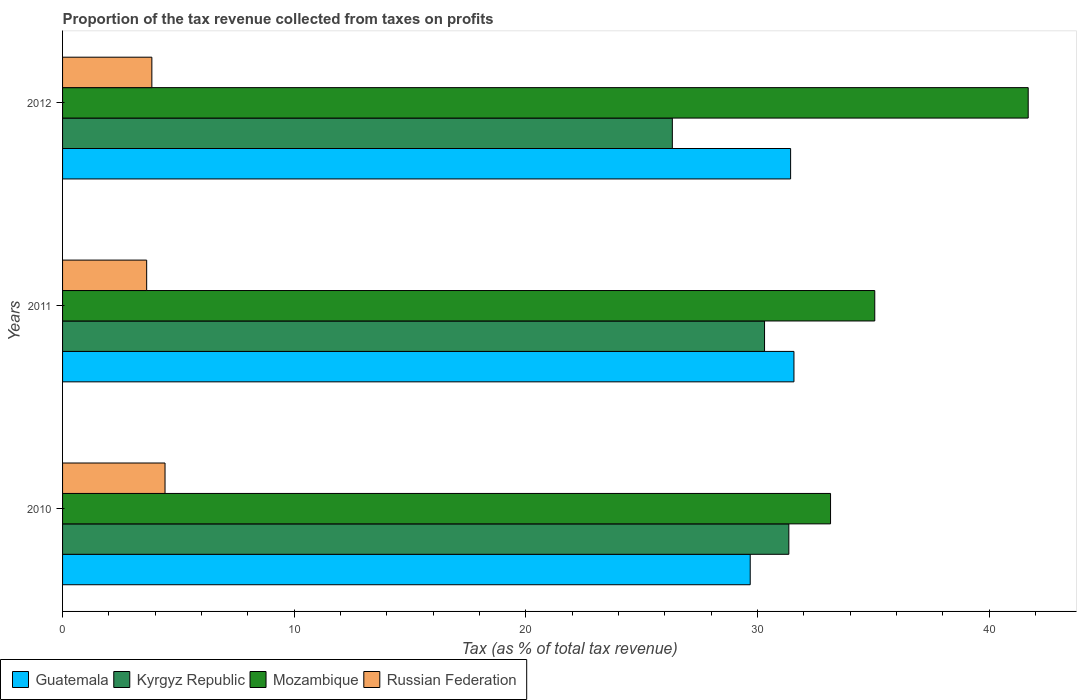Are the number of bars per tick equal to the number of legend labels?
Offer a very short reply. Yes. How many bars are there on the 1st tick from the top?
Offer a very short reply. 4. How many bars are there on the 3rd tick from the bottom?
Your response must be concise. 4. In how many cases, is the number of bars for a given year not equal to the number of legend labels?
Offer a very short reply. 0. What is the proportion of the tax revenue collected in Russian Federation in 2010?
Make the answer very short. 4.42. Across all years, what is the maximum proportion of the tax revenue collected in Mozambique?
Provide a succinct answer. 41.69. Across all years, what is the minimum proportion of the tax revenue collected in Russian Federation?
Offer a very short reply. 3.63. In which year was the proportion of the tax revenue collected in Kyrgyz Republic maximum?
Provide a short and direct response. 2010. What is the total proportion of the tax revenue collected in Kyrgyz Republic in the graph?
Make the answer very short. 87.99. What is the difference between the proportion of the tax revenue collected in Mozambique in 2010 and that in 2012?
Your response must be concise. -8.53. What is the difference between the proportion of the tax revenue collected in Mozambique in 2010 and the proportion of the tax revenue collected in Russian Federation in 2011?
Your answer should be compact. 29.52. What is the average proportion of the tax revenue collected in Guatemala per year?
Your answer should be compact. 30.9. In the year 2011, what is the difference between the proportion of the tax revenue collected in Guatemala and proportion of the tax revenue collected in Russian Federation?
Keep it short and to the point. 27.94. What is the ratio of the proportion of the tax revenue collected in Mozambique in 2011 to that in 2012?
Keep it short and to the point. 0.84. Is the difference between the proportion of the tax revenue collected in Guatemala in 2010 and 2011 greater than the difference between the proportion of the tax revenue collected in Russian Federation in 2010 and 2011?
Keep it short and to the point. No. What is the difference between the highest and the second highest proportion of the tax revenue collected in Kyrgyz Republic?
Ensure brevity in your answer.  1.05. What is the difference between the highest and the lowest proportion of the tax revenue collected in Guatemala?
Make the answer very short. 1.89. In how many years, is the proportion of the tax revenue collected in Kyrgyz Republic greater than the average proportion of the tax revenue collected in Kyrgyz Republic taken over all years?
Your answer should be very brief. 2. What does the 1st bar from the top in 2011 represents?
Make the answer very short. Russian Federation. What does the 3rd bar from the bottom in 2010 represents?
Your answer should be very brief. Mozambique. How many bars are there?
Offer a terse response. 12. How many years are there in the graph?
Make the answer very short. 3. What is the difference between two consecutive major ticks on the X-axis?
Offer a terse response. 10. Does the graph contain grids?
Keep it short and to the point. No. How are the legend labels stacked?
Your response must be concise. Horizontal. What is the title of the graph?
Offer a terse response. Proportion of the tax revenue collected from taxes on profits. Does "Switzerland" appear as one of the legend labels in the graph?
Offer a very short reply. No. What is the label or title of the X-axis?
Offer a very short reply. Tax (as % of total tax revenue). What is the label or title of the Y-axis?
Your answer should be compact. Years. What is the Tax (as % of total tax revenue) of Guatemala in 2010?
Offer a terse response. 29.69. What is the Tax (as % of total tax revenue) in Kyrgyz Republic in 2010?
Give a very brief answer. 31.36. What is the Tax (as % of total tax revenue) of Mozambique in 2010?
Make the answer very short. 33.16. What is the Tax (as % of total tax revenue) in Russian Federation in 2010?
Make the answer very short. 4.42. What is the Tax (as % of total tax revenue) of Guatemala in 2011?
Your answer should be compact. 31.58. What is the Tax (as % of total tax revenue) of Kyrgyz Republic in 2011?
Offer a terse response. 30.31. What is the Tax (as % of total tax revenue) of Mozambique in 2011?
Provide a succinct answer. 35.06. What is the Tax (as % of total tax revenue) of Russian Federation in 2011?
Your answer should be compact. 3.63. What is the Tax (as % of total tax revenue) of Guatemala in 2012?
Ensure brevity in your answer.  31.43. What is the Tax (as % of total tax revenue) of Kyrgyz Republic in 2012?
Offer a very short reply. 26.33. What is the Tax (as % of total tax revenue) of Mozambique in 2012?
Offer a terse response. 41.69. What is the Tax (as % of total tax revenue) in Russian Federation in 2012?
Make the answer very short. 3.85. Across all years, what is the maximum Tax (as % of total tax revenue) in Guatemala?
Your response must be concise. 31.58. Across all years, what is the maximum Tax (as % of total tax revenue) in Kyrgyz Republic?
Provide a succinct answer. 31.36. Across all years, what is the maximum Tax (as % of total tax revenue) of Mozambique?
Provide a succinct answer. 41.69. Across all years, what is the maximum Tax (as % of total tax revenue) of Russian Federation?
Offer a very short reply. 4.42. Across all years, what is the minimum Tax (as % of total tax revenue) in Guatemala?
Keep it short and to the point. 29.69. Across all years, what is the minimum Tax (as % of total tax revenue) in Kyrgyz Republic?
Your answer should be very brief. 26.33. Across all years, what is the minimum Tax (as % of total tax revenue) of Mozambique?
Your answer should be very brief. 33.16. Across all years, what is the minimum Tax (as % of total tax revenue) in Russian Federation?
Offer a terse response. 3.63. What is the total Tax (as % of total tax revenue) in Guatemala in the graph?
Offer a terse response. 92.69. What is the total Tax (as % of total tax revenue) in Kyrgyz Republic in the graph?
Provide a succinct answer. 87.99. What is the total Tax (as % of total tax revenue) in Mozambique in the graph?
Offer a terse response. 109.91. What is the total Tax (as % of total tax revenue) in Russian Federation in the graph?
Your response must be concise. 11.91. What is the difference between the Tax (as % of total tax revenue) of Guatemala in 2010 and that in 2011?
Keep it short and to the point. -1.89. What is the difference between the Tax (as % of total tax revenue) of Kyrgyz Republic in 2010 and that in 2011?
Offer a very short reply. 1.05. What is the difference between the Tax (as % of total tax revenue) of Mozambique in 2010 and that in 2011?
Offer a very short reply. -1.91. What is the difference between the Tax (as % of total tax revenue) of Russian Federation in 2010 and that in 2011?
Make the answer very short. 0.79. What is the difference between the Tax (as % of total tax revenue) in Guatemala in 2010 and that in 2012?
Your answer should be very brief. -1.74. What is the difference between the Tax (as % of total tax revenue) in Kyrgyz Republic in 2010 and that in 2012?
Your answer should be compact. 5.03. What is the difference between the Tax (as % of total tax revenue) of Mozambique in 2010 and that in 2012?
Give a very brief answer. -8.53. What is the difference between the Tax (as % of total tax revenue) in Russian Federation in 2010 and that in 2012?
Ensure brevity in your answer.  0.57. What is the difference between the Tax (as % of total tax revenue) of Guatemala in 2011 and that in 2012?
Your response must be concise. 0.14. What is the difference between the Tax (as % of total tax revenue) in Kyrgyz Republic in 2011 and that in 2012?
Your response must be concise. 3.98. What is the difference between the Tax (as % of total tax revenue) in Mozambique in 2011 and that in 2012?
Offer a terse response. -6.62. What is the difference between the Tax (as % of total tax revenue) in Russian Federation in 2011 and that in 2012?
Provide a short and direct response. -0.22. What is the difference between the Tax (as % of total tax revenue) of Guatemala in 2010 and the Tax (as % of total tax revenue) of Kyrgyz Republic in 2011?
Give a very brief answer. -0.62. What is the difference between the Tax (as % of total tax revenue) in Guatemala in 2010 and the Tax (as % of total tax revenue) in Mozambique in 2011?
Your response must be concise. -5.38. What is the difference between the Tax (as % of total tax revenue) in Guatemala in 2010 and the Tax (as % of total tax revenue) in Russian Federation in 2011?
Your answer should be compact. 26.06. What is the difference between the Tax (as % of total tax revenue) in Kyrgyz Republic in 2010 and the Tax (as % of total tax revenue) in Mozambique in 2011?
Ensure brevity in your answer.  -3.71. What is the difference between the Tax (as % of total tax revenue) of Kyrgyz Republic in 2010 and the Tax (as % of total tax revenue) of Russian Federation in 2011?
Ensure brevity in your answer.  27.72. What is the difference between the Tax (as % of total tax revenue) in Mozambique in 2010 and the Tax (as % of total tax revenue) in Russian Federation in 2011?
Give a very brief answer. 29.52. What is the difference between the Tax (as % of total tax revenue) in Guatemala in 2010 and the Tax (as % of total tax revenue) in Kyrgyz Republic in 2012?
Provide a succinct answer. 3.36. What is the difference between the Tax (as % of total tax revenue) in Guatemala in 2010 and the Tax (as % of total tax revenue) in Mozambique in 2012?
Offer a terse response. -12. What is the difference between the Tax (as % of total tax revenue) of Guatemala in 2010 and the Tax (as % of total tax revenue) of Russian Federation in 2012?
Ensure brevity in your answer.  25.83. What is the difference between the Tax (as % of total tax revenue) in Kyrgyz Republic in 2010 and the Tax (as % of total tax revenue) in Mozambique in 2012?
Keep it short and to the point. -10.33. What is the difference between the Tax (as % of total tax revenue) in Kyrgyz Republic in 2010 and the Tax (as % of total tax revenue) in Russian Federation in 2012?
Ensure brevity in your answer.  27.5. What is the difference between the Tax (as % of total tax revenue) of Mozambique in 2010 and the Tax (as % of total tax revenue) of Russian Federation in 2012?
Your response must be concise. 29.3. What is the difference between the Tax (as % of total tax revenue) in Guatemala in 2011 and the Tax (as % of total tax revenue) in Kyrgyz Republic in 2012?
Ensure brevity in your answer.  5.25. What is the difference between the Tax (as % of total tax revenue) in Guatemala in 2011 and the Tax (as % of total tax revenue) in Mozambique in 2012?
Give a very brief answer. -10.11. What is the difference between the Tax (as % of total tax revenue) of Guatemala in 2011 and the Tax (as % of total tax revenue) of Russian Federation in 2012?
Keep it short and to the point. 27.72. What is the difference between the Tax (as % of total tax revenue) in Kyrgyz Republic in 2011 and the Tax (as % of total tax revenue) in Mozambique in 2012?
Your answer should be compact. -11.38. What is the difference between the Tax (as % of total tax revenue) of Kyrgyz Republic in 2011 and the Tax (as % of total tax revenue) of Russian Federation in 2012?
Offer a very short reply. 26.45. What is the difference between the Tax (as % of total tax revenue) in Mozambique in 2011 and the Tax (as % of total tax revenue) in Russian Federation in 2012?
Your answer should be compact. 31.21. What is the average Tax (as % of total tax revenue) in Guatemala per year?
Keep it short and to the point. 30.9. What is the average Tax (as % of total tax revenue) in Kyrgyz Republic per year?
Provide a succinct answer. 29.33. What is the average Tax (as % of total tax revenue) in Mozambique per year?
Make the answer very short. 36.64. What is the average Tax (as % of total tax revenue) of Russian Federation per year?
Provide a short and direct response. 3.97. In the year 2010, what is the difference between the Tax (as % of total tax revenue) in Guatemala and Tax (as % of total tax revenue) in Kyrgyz Republic?
Make the answer very short. -1.67. In the year 2010, what is the difference between the Tax (as % of total tax revenue) of Guatemala and Tax (as % of total tax revenue) of Mozambique?
Your answer should be compact. -3.47. In the year 2010, what is the difference between the Tax (as % of total tax revenue) of Guatemala and Tax (as % of total tax revenue) of Russian Federation?
Your answer should be very brief. 25.26. In the year 2010, what is the difference between the Tax (as % of total tax revenue) in Kyrgyz Republic and Tax (as % of total tax revenue) in Mozambique?
Ensure brevity in your answer.  -1.8. In the year 2010, what is the difference between the Tax (as % of total tax revenue) in Kyrgyz Republic and Tax (as % of total tax revenue) in Russian Federation?
Your answer should be compact. 26.93. In the year 2010, what is the difference between the Tax (as % of total tax revenue) of Mozambique and Tax (as % of total tax revenue) of Russian Federation?
Offer a terse response. 28.73. In the year 2011, what is the difference between the Tax (as % of total tax revenue) of Guatemala and Tax (as % of total tax revenue) of Kyrgyz Republic?
Ensure brevity in your answer.  1.27. In the year 2011, what is the difference between the Tax (as % of total tax revenue) of Guatemala and Tax (as % of total tax revenue) of Mozambique?
Make the answer very short. -3.49. In the year 2011, what is the difference between the Tax (as % of total tax revenue) in Guatemala and Tax (as % of total tax revenue) in Russian Federation?
Offer a terse response. 27.94. In the year 2011, what is the difference between the Tax (as % of total tax revenue) in Kyrgyz Republic and Tax (as % of total tax revenue) in Mozambique?
Provide a short and direct response. -4.76. In the year 2011, what is the difference between the Tax (as % of total tax revenue) of Kyrgyz Republic and Tax (as % of total tax revenue) of Russian Federation?
Make the answer very short. 26.68. In the year 2011, what is the difference between the Tax (as % of total tax revenue) of Mozambique and Tax (as % of total tax revenue) of Russian Federation?
Give a very brief answer. 31.43. In the year 2012, what is the difference between the Tax (as % of total tax revenue) in Guatemala and Tax (as % of total tax revenue) in Kyrgyz Republic?
Your answer should be compact. 5.11. In the year 2012, what is the difference between the Tax (as % of total tax revenue) in Guatemala and Tax (as % of total tax revenue) in Mozambique?
Your response must be concise. -10.26. In the year 2012, what is the difference between the Tax (as % of total tax revenue) of Guatemala and Tax (as % of total tax revenue) of Russian Federation?
Ensure brevity in your answer.  27.58. In the year 2012, what is the difference between the Tax (as % of total tax revenue) of Kyrgyz Republic and Tax (as % of total tax revenue) of Mozambique?
Your answer should be very brief. -15.36. In the year 2012, what is the difference between the Tax (as % of total tax revenue) of Kyrgyz Republic and Tax (as % of total tax revenue) of Russian Federation?
Offer a very short reply. 22.47. In the year 2012, what is the difference between the Tax (as % of total tax revenue) of Mozambique and Tax (as % of total tax revenue) of Russian Federation?
Provide a succinct answer. 37.83. What is the ratio of the Tax (as % of total tax revenue) in Guatemala in 2010 to that in 2011?
Keep it short and to the point. 0.94. What is the ratio of the Tax (as % of total tax revenue) in Kyrgyz Republic in 2010 to that in 2011?
Provide a short and direct response. 1.03. What is the ratio of the Tax (as % of total tax revenue) in Mozambique in 2010 to that in 2011?
Offer a terse response. 0.95. What is the ratio of the Tax (as % of total tax revenue) in Russian Federation in 2010 to that in 2011?
Your answer should be very brief. 1.22. What is the ratio of the Tax (as % of total tax revenue) in Guatemala in 2010 to that in 2012?
Ensure brevity in your answer.  0.94. What is the ratio of the Tax (as % of total tax revenue) in Kyrgyz Republic in 2010 to that in 2012?
Your response must be concise. 1.19. What is the ratio of the Tax (as % of total tax revenue) of Mozambique in 2010 to that in 2012?
Your answer should be compact. 0.8. What is the ratio of the Tax (as % of total tax revenue) of Russian Federation in 2010 to that in 2012?
Keep it short and to the point. 1.15. What is the ratio of the Tax (as % of total tax revenue) in Guatemala in 2011 to that in 2012?
Offer a terse response. 1. What is the ratio of the Tax (as % of total tax revenue) of Kyrgyz Republic in 2011 to that in 2012?
Offer a very short reply. 1.15. What is the ratio of the Tax (as % of total tax revenue) of Mozambique in 2011 to that in 2012?
Make the answer very short. 0.84. What is the ratio of the Tax (as % of total tax revenue) of Russian Federation in 2011 to that in 2012?
Make the answer very short. 0.94. What is the difference between the highest and the second highest Tax (as % of total tax revenue) of Guatemala?
Keep it short and to the point. 0.14. What is the difference between the highest and the second highest Tax (as % of total tax revenue) in Kyrgyz Republic?
Provide a short and direct response. 1.05. What is the difference between the highest and the second highest Tax (as % of total tax revenue) of Mozambique?
Offer a very short reply. 6.62. What is the difference between the highest and the second highest Tax (as % of total tax revenue) in Russian Federation?
Ensure brevity in your answer.  0.57. What is the difference between the highest and the lowest Tax (as % of total tax revenue) of Guatemala?
Offer a terse response. 1.89. What is the difference between the highest and the lowest Tax (as % of total tax revenue) of Kyrgyz Republic?
Ensure brevity in your answer.  5.03. What is the difference between the highest and the lowest Tax (as % of total tax revenue) of Mozambique?
Offer a terse response. 8.53. What is the difference between the highest and the lowest Tax (as % of total tax revenue) in Russian Federation?
Your response must be concise. 0.79. 